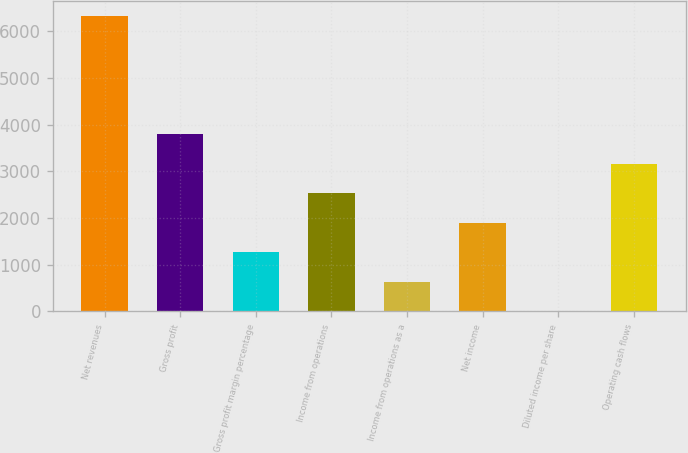Convert chart. <chart><loc_0><loc_0><loc_500><loc_500><bar_chart><fcel>Net revenues<fcel>Gross profit<fcel>Gross profit margin percentage<fcel>Income from operations<fcel>Income from operations as a<fcel>Net income<fcel>Diluted income per share<fcel>Operating cash flows<nl><fcel>6332.4<fcel>3799.97<fcel>1267.57<fcel>2533.77<fcel>634.47<fcel>1900.67<fcel>1.37<fcel>3166.87<nl></chart> 